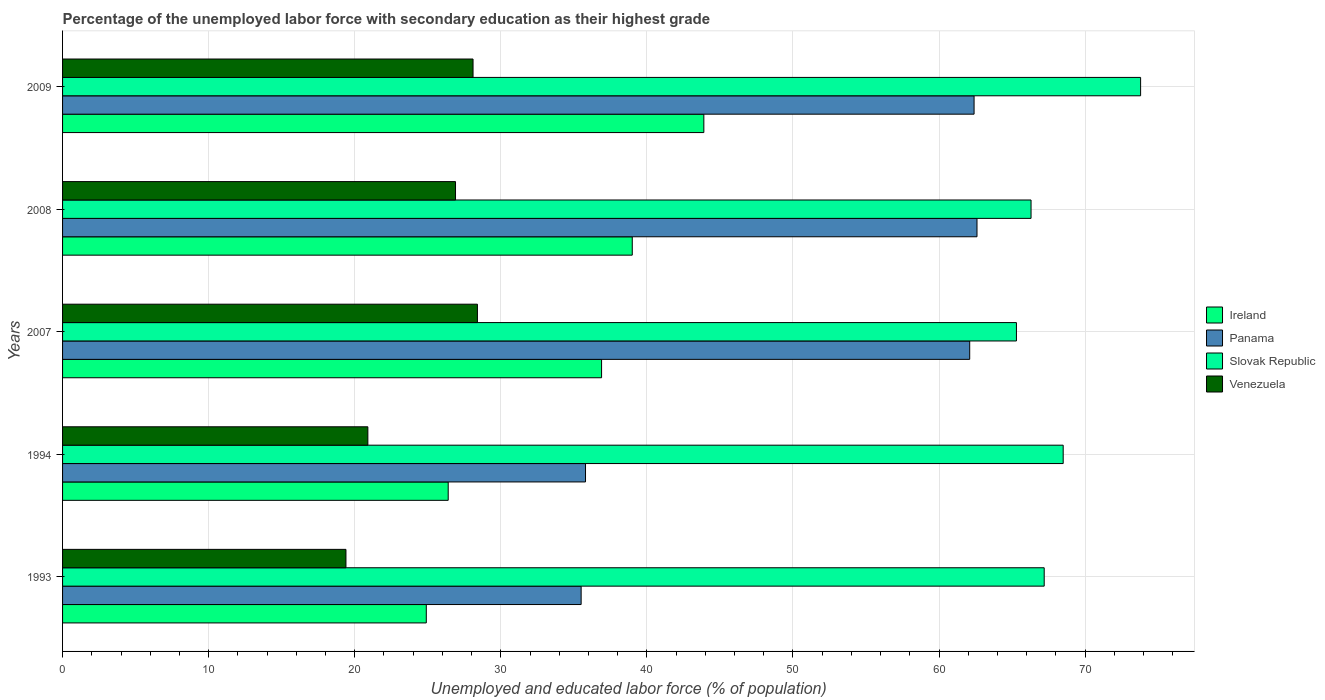How many different coloured bars are there?
Give a very brief answer. 4. Are the number of bars per tick equal to the number of legend labels?
Your response must be concise. Yes. Are the number of bars on each tick of the Y-axis equal?
Provide a short and direct response. Yes. How many bars are there on the 2nd tick from the top?
Your response must be concise. 4. What is the label of the 4th group of bars from the top?
Your answer should be very brief. 1994. What is the percentage of the unemployed labor force with secondary education in Panama in 1993?
Provide a succinct answer. 35.5. Across all years, what is the maximum percentage of the unemployed labor force with secondary education in Panama?
Provide a succinct answer. 62.6. Across all years, what is the minimum percentage of the unemployed labor force with secondary education in Panama?
Your answer should be very brief. 35.5. In which year was the percentage of the unemployed labor force with secondary education in Ireland minimum?
Ensure brevity in your answer.  1993. What is the total percentage of the unemployed labor force with secondary education in Slovak Republic in the graph?
Give a very brief answer. 341.1. What is the difference between the percentage of the unemployed labor force with secondary education in Venezuela in 1993 and that in 2008?
Your answer should be compact. -7.5. What is the difference between the percentage of the unemployed labor force with secondary education in Slovak Republic in 1994 and the percentage of the unemployed labor force with secondary education in Venezuela in 2008?
Offer a very short reply. 41.6. What is the average percentage of the unemployed labor force with secondary education in Ireland per year?
Make the answer very short. 34.22. In the year 1994, what is the difference between the percentage of the unemployed labor force with secondary education in Panama and percentage of the unemployed labor force with secondary education in Venezuela?
Provide a short and direct response. 14.9. What is the ratio of the percentage of the unemployed labor force with secondary education in Venezuela in 1994 to that in 2009?
Make the answer very short. 0.74. Is the percentage of the unemployed labor force with secondary education in Ireland in 1993 less than that in 1994?
Offer a very short reply. Yes. Is the difference between the percentage of the unemployed labor force with secondary education in Panama in 2007 and 2009 greater than the difference between the percentage of the unemployed labor force with secondary education in Venezuela in 2007 and 2009?
Provide a short and direct response. No. What is the difference between the highest and the second highest percentage of the unemployed labor force with secondary education in Ireland?
Your answer should be very brief. 4.9. What is the difference between the highest and the lowest percentage of the unemployed labor force with secondary education in Panama?
Offer a very short reply. 27.1. In how many years, is the percentage of the unemployed labor force with secondary education in Slovak Republic greater than the average percentage of the unemployed labor force with secondary education in Slovak Republic taken over all years?
Your response must be concise. 2. Is it the case that in every year, the sum of the percentage of the unemployed labor force with secondary education in Panama and percentage of the unemployed labor force with secondary education in Venezuela is greater than the sum of percentage of the unemployed labor force with secondary education in Ireland and percentage of the unemployed labor force with secondary education in Slovak Republic?
Ensure brevity in your answer.  No. What does the 2nd bar from the top in 1993 represents?
Give a very brief answer. Slovak Republic. What does the 4th bar from the bottom in 1994 represents?
Give a very brief answer. Venezuela. How many years are there in the graph?
Offer a terse response. 5. What is the difference between two consecutive major ticks on the X-axis?
Your answer should be very brief. 10. Where does the legend appear in the graph?
Make the answer very short. Center right. What is the title of the graph?
Ensure brevity in your answer.  Percentage of the unemployed labor force with secondary education as their highest grade. What is the label or title of the X-axis?
Give a very brief answer. Unemployed and educated labor force (% of population). What is the label or title of the Y-axis?
Offer a very short reply. Years. What is the Unemployed and educated labor force (% of population) in Ireland in 1993?
Ensure brevity in your answer.  24.9. What is the Unemployed and educated labor force (% of population) of Panama in 1993?
Provide a succinct answer. 35.5. What is the Unemployed and educated labor force (% of population) of Slovak Republic in 1993?
Keep it short and to the point. 67.2. What is the Unemployed and educated labor force (% of population) in Venezuela in 1993?
Provide a short and direct response. 19.4. What is the Unemployed and educated labor force (% of population) of Ireland in 1994?
Make the answer very short. 26.4. What is the Unemployed and educated labor force (% of population) of Panama in 1994?
Offer a very short reply. 35.8. What is the Unemployed and educated labor force (% of population) of Slovak Republic in 1994?
Make the answer very short. 68.5. What is the Unemployed and educated labor force (% of population) in Venezuela in 1994?
Provide a succinct answer. 20.9. What is the Unemployed and educated labor force (% of population) of Ireland in 2007?
Provide a short and direct response. 36.9. What is the Unemployed and educated labor force (% of population) in Panama in 2007?
Your answer should be very brief. 62.1. What is the Unemployed and educated labor force (% of population) in Slovak Republic in 2007?
Ensure brevity in your answer.  65.3. What is the Unemployed and educated labor force (% of population) of Venezuela in 2007?
Provide a short and direct response. 28.4. What is the Unemployed and educated labor force (% of population) in Panama in 2008?
Offer a terse response. 62.6. What is the Unemployed and educated labor force (% of population) of Slovak Republic in 2008?
Your answer should be compact. 66.3. What is the Unemployed and educated labor force (% of population) in Venezuela in 2008?
Provide a short and direct response. 26.9. What is the Unemployed and educated labor force (% of population) in Ireland in 2009?
Your response must be concise. 43.9. What is the Unemployed and educated labor force (% of population) in Panama in 2009?
Your answer should be compact. 62.4. What is the Unemployed and educated labor force (% of population) of Slovak Republic in 2009?
Ensure brevity in your answer.  73.8. What is the Unemployed and educated labor force (% of population) of Venezuela in 2009?
Make the answer very short. 28.1. Across all years, what is the maximum Unemployed and educated labor force (% of population) of Ireland?
Your response must be concise. 43.9. Across all years, what is the maximum Unemployed and educated labor force (% of population) of Panama?
Give a very brief answer. 62.6. Across all years, what is the maximum Unemployed and educated labor force (% of population) in Slovak Republic?
Provide a succinct answer. 73.8. Across all years, what is the maximum Unemployed and educated labor force (% of population) of Venezuela?
Offer a terse response. 28.4. Across all years, what is the minimum Unemployed and educated labor force (% of population) in Ireland?
Give a very brief answer. 24.9. Across all years, what is the minimum Unemployed and educated labor force (% of population) of Panama?
Your answer should be compact. 35.5. Across all years, what is the minimum Unemployed and educated labor force (% of population) of Slovak Republic?
Keep it short and to the point. 65.3. Across all years, what is the minimum Unemployed and educated labor force (% of population) in Venezuela?
Ensure brevity in your answer.  19.4. What is the total Unemployed and educated labor force (% of population) in Ireland in the graph?
Give a very brief answer. 171.1. What is the total Unemployed and educated labor force (% of population) in Panama in the graph?
Your response must be concise. 258.4. What is the total Unemployed and educated labor force (% of population) of Slovak Republic in the graph?
Keep it short and to the point. 341.1. What is the total Unemployed and educated labor force (% of population) in Venezuela in the graph?
Offer a terse response. 123.7. What is the difference between the Unemployed and educated labor force (% of population) in Ireland in 1993 and that in 1994?
Make the answer very short. -1.5. What is the difference between the Unemployed and educated labor force (% of population) of Panama in 1993 and that in 1994?
Provide a succinct answer. -0.3. What is the difference between the Unemployed and educated labor force (% of population) in Panama in 1993 and that in 2007?
Offer a terse response. -26.6. What is the difference between the Unemployed and educated labor force (% of population) in Slovak Republic in 1993 and that in 2007?
Your response must be concise. 1.9. What is the difference between the Unemployed and educated labor force (% of population) of Ireland in 1993 and that in 2008?
Make the answer very short. -14.1. What is the difference between the Unemployed and educated labor force (% of population) of Panama in 1993 and that in 2008?
Make the answer very short. -27.1. What is the difference between the Unemployed and educated labor force (% of population) of Ireland in 1993 and that in 2009?
Make the answer very short. -19. What is the difference between the Unemployed and educated labor force (% of population) in Panama in 1993 and that in 2009?
Your answer should be very brief. -26.9. What is the difference between the Unemployed and educated labor force (% of population) of Slovak Republic in 1993 and that in 2009?
Your answer should be very brief. -6.6. What is the difference between the Unemployed and educated labor force (% of population) in Panama in 1994 and that in 2007?
Provide a succinct answer. -26.3. What is the difference between the Unemployed and educated labor force (% of population) of Slovak Republic in 1994 and that in 2007?
Offer a very short reply. 3.2. What is the difference between the Unemployed and educated labor force (% of population) of Venezuela in 1994 and that in 2007?
Keep it short and to the point. -7.5. What is the difference between the Unemployed and educated labor force (% of population) in Ireland in 1994 and that in 2008?
Offer a terse response. -12.6. What is the difference between the Unemployed and educated labor force (% of population) of Panama in 1994 and that in 2008?
Provide a short and direct response. -26.8. What is the difference between the Unemployed and educated labor force (% of population) in Ireland in 1994 and that in 2009?
Your answer should be very brief. -17.5. What is the difference between the Unemployed and educated labor force (% of population) in Panama in 1994 and that in 2009?
Make the answer very short. -26.6. What is the difference between the Unemployed and educated labor force (% of population) of Venezuela in 1994 and that in 2009?
Ensure brevity in your answer.  -7.2. What is the difference between the Unemployed and educated labor force (% of population) of Slovak Republic in 2007 and that in 2008?
Your answer should be very brief. -1. What is the difference between the Unemployed and educated labor force (% of population) in Panama in 2007 and that in 2009?
Offer a very short reply. -0.3. What is the difference between the Unemployed and educated labor force (% of population) in Slovak Republic in 2007 and that in 2009?
Your answer should be compact. -8.5. What is the difference between the Unemployed and educated labor force (% of population) of Ireland in 2008 and that in 2009?
Your answer should be compact. -4.9. What is the difference between the Unemployed and educated labor force (% of population) of Panama in 2008 and that in 2009?
Offer a terse response. 0.2. What is the difference between the Unemployed and educated labor force (% of population) of Slovak Republic in 2008 and that in 2009?
Offer a very short reply. -7.5. What is the difference between the Unemployed and educated labor force (% of population) in Venezuela in 2008 and that in 2009?
Offer a terse response. -1.2. What is the difference between the Unemployed and educated labor force (% of population) in Ireland in 1993 and the Unemployed and educated labor force (% of population) in Panama in 1994?
Offer a terse response. -10.9. What is the difference between the Unemployed and educated labor force (% of population) in Ireland in 1993 and the Unemployed and educated labor force (% of population) in Slovak Republic in 1994?
Ensure brevity in your answer.  -43.6. What is the difference between the Unemployed and educated labor force (% of population) in Panama in 1993 and the Unemployed and educated labor force (% of population) in Slovak Republic in 1994?
Provide a succinct answer. -33. What is the difference between the Unemployed and educated labor force (% of population) in Panama in 1993 and the Unemployed and educated labor force (% of population) in Venezuela in 1994?
Keep it short and to the point. 14.6. What is the difference between the Unemployed and educated labor force (% of population) of Slovak Republic in 1993 and the Unemployed and educated labor force (% of population) of Venezuela in 1994?
Make the answer very short. 46.3. What is the difference between the Unemployed and educated labor force (% of population) of Ireland in 1993 and the Unemployed and educated labor force (% of population) of Panama in 2007?
Provide a succinct answer. -37.2. What is the difference between the Unemployed and educated labor force (% of population) in Ireland in 1993 and the Unemployed and educated labor force (% of population) in Slovak Republic in 2007?
Your answer should be compact. -40.4. What is the difference between the Unemployed and educated labor force (% of population) of Ireland in 1993 and the Unemployed and educated labor force (% of population) of Venezuela in 2007?
Ensure brevity in your answer.  -3.5. What is the difference between the Unemployed and educated labor force (% of population) of Panama in 1993 and the Unemployed and educated labor force (% of population) of Slovak Republic in 2007?
Your answer should be compact. -29.8. What is the difference between the Unemployed and educated labor force (% of population) of Panama in 1993 and the Unemployed and educated labor force (% of population) of Venezuela in 2007?
Your response must be concise. 7.1. What is the difference between the Unemployed and educated labor force (% of population) in Slovak Republic in 1993 and the Unemployed and educated labor force (% of population) in Venezuela in 2007?
Give a very brief answer. 38.8. What is the difference between the Unemployed and educated labor force (% of population) in Ireland in 1993 and the Unemployed and educated labor force (% of population) in Panama in 2008?
Your answer should be compact. -37.7. What is the difference between the Unemployed and educated labor force (% of population) of Ireland in 1993 and the Unemployed and educated labor force (% of population) of Slovak Republic in 2008?
Your answer should be compact. -41.4. What is the difference between the Unemployed and educated labor force (% of population) in Panama in 1993 and the Unemployed and educated labor force (% of population) in Slovak Republic in 2008?
Provide a short and direct response. -30.8. What is the difference between the Unemployed and educated labor force (% of population) in Slovak Republic in 1993 and the Unemployed and educated labor force (% of population) in Venezuela in 2008?
Your answer should be compact. 40.3. What is the difference between the Unemployed and educated labor force (% of population) in Ireland in 1993 and the Unemployed and educated labor force (% of population) in Panama in 2009?
Give a very brief answer. -37.5. What is the difference between the Unemployed and educated labor force (% of population) of Ireland in 1993 and the Unemployed and educated labor force (% of population) of Slovak Republic in 2009?
Your answer should be compact. -48.9. What is the difference between the Unemployed and educated labor force (% of population) of Panama in 1993 and the Unemployed and educated labor force (% of population) of Slovak Republic in 2009?
Make the answer very short. -38.3. What is the difference between the Unemployed and educated labor force (% of population) of Panama in 1993 and the Unemployed and educated labor force (% of population) of Venezuela in 2009?
Offer a terse response. 7.4. What is the difference between the Unemployed and educated labor force (% of population) of Slovak Republic in 1993 and the Unemployed and educated labor force (% of population) of Venezuela in 2009?
Provide a succinct answer. 39.1. What is the difference between the Unemployed and educated labor force (% of population) in Ireland in 1994 and the Unemployed and educated labor force (% of population) in Panama in 2007?
Offer a terse response. -35.7. What is the difference between the Unemployed and educated labor force (% of population) of Ireland in 1994 and the Unemployed and educated labor force (% of population) of Slovak Republic in 2007?
Your answer should be very brief. -38.9. What is the difference between the Unemployed and educated labor force (% of population) in Ireland in 1994 and the Unemployed and educated labor force (% of population) in Venezuela in 2007?
Offer a very short reply. -2. What is the difference between the Unemployed and educated labor force (% of population) in Panama in 1994 and the Unemployed and educated labor force (% of population) in Slovak Republic in 2007?
Offer a very short reply. -29.5. What is the difference between the Unemployed and educated labor force (% of population) of Panama in 1994 and the Unemployed and educated labor force (% of population) of Venezuela in 2007?
Your response must be concise. 7.4. What is the difference between the Unemployed and educated labor force (% of population) of Slovak Republic in 1994 and the Unemployed and educated labor force (% of population) of Venezuela in 2007?
Make the answer very short. 40.1. What is the difference between the Unemployed and educated labor force (% of population) in Ireland in 1994 and the Unemployed and educated labor force (% of population) in Panama in 2008?
Offer a very short reply. -36.2. What is the difference between the Unemployed and educated labor force (% of population) in Ireland in 1994 and the Unemployed and educated labor force (% of population) in Slovak Republic in 2008?
Keep it short and to the point. -39.9. What is the difference between the Unemployed and educated labor force (% of population) in Panama in 1994 and the Unemployed and educated labor force (% of population) in Slovak Republic in 2008?
Your answer should be very brief. -30.5. What is the difference between the Unemployed and educated labor force (% of population) of Panama in 1994 and the Unemployed and educated labor force (% of population) of Venezuela in 2008?
Your response must be concise. 8.9. What is the difference between the Unemployed and educated labor force (% of population) of Slovak Republic in 1994 and the Unemployed and educated labor force (% of population) of Venezuela in 2008?
Offer a terse response. 41.6. What is the difference between the Unemployed and educated labor force (% of population) in Ireland in 1994 and the Unemployed and educated labor force (% of population) in Panama in 2009?
Keep it short and to the point. -36. What is the difference between the Unemployed and educated labor force (% of population) of Ireland in 1994 and the Unemployed and educated labor force (% of population) of Slovak Republic in 2009?
Keep it short and to the point. -47.4. What is the difference between the Unemployed and educated labor force (% of population) in Ireland in 1994 and the Unemployed and educated labor force (% of population) in Venezuela in 2009?
Ensure brevity in your answer.  -1.7. What is the difference between the Unemployed and educated labor force (% of population) in Panama in 1994 and the Unemployed and educated labor force (% of population) in Slovak Republic in 2009?
Ensure brevity in your answer.  -38. What is the difference between the Unemployed and educated labor force (% of population) in Panama in 1994 and the Unemployed and educated labor force (% of population) in Venezuela in 2009?
Your answer should be compact. 7.7. What is the difference between the Unemployed and educated labor force (% of population) in Slovak Republic in 1994 and the Unemployed and educated labor force (% of population) in Venezuela in 2009?
Ensure brevity in your answer.  40.4. What is the difference between the Unemployed and educated labor force (% of population) in Ireland in 2007 and the Unemployed and educated labor force (% of population) in Panama in 2008?
Your response must be concise. -25.7. What is the difference between the Unemployed and educated labor force (% of population) of Ireland in 2007 and the Unemployed and educated labor force (% of population) of Slovak Republic in 2008?
Provide a short and direct response. -29.4. What is the difference between the Unemployed and educated labor force (% of population) in Panama in 2007 and the Unemployed and educated labor force (% of population) in Venezuela in 2008?
Provide a short and direct response. 35.2. What is the difference between the Unemployed and educated labor force (% of population) in Slovak Republic in 2007 and the Unemployed and educated labor force (% of population) in Venezuela in 2008?
Provide a short and direct response. 38.4. What is the difference between the Unemployed and educated labor force (% of population) of Ireland in 2007 and the Unemployed and educated labor force (% of population) of Panama in 2009?
Offer a terse response. -25.5. What is the difference between the Unemployed and educated labor force (% of population) of Ireland in 2007 and the Unemployed and educated labor force (% of population) of Slovak Republic in 2009?
Provide a short and direct response. -36.9. What is the difference between the Unemployed and educated labor force (% of population) of Ireland in 2007 and the Unemployed and educated labor force (% of population) of Venezuela in 2009?
Ensure brevity in your answer.  8.8. What is the difference between the Unemployed and educated labor force (% of population) of Panama in 2007 and the Unemployed and educated labor force (% of population) of Slovak Republic in 2009?
Keep it short and to the point. -11.7. What is the difference between the Unemployed and educated labor force (% of population) in Panama in 2007 and the Unemployed and educated labor force (% of population) in Venezuela in 2009?
Your response must be concise. 34. What is the difference between the Unemployed and educated labor force (% of population) of Slovak Republic in 2007 and the Unemployed and educated labor force (% of population) of Venezuela in 2009?
Offer a very short reply. 37.2. What is the difference between the Unemployed and educated labor force (% of population) in Ireland in 2008 and the Unemployed and educated labor force (% of population) in Panama in 2009?
Make the answer very short. -23.4. What is the difference between the Unemployed and educated labor force (% of population) in Ireland in 2008 and the Unemployed and educated labor force (% of population) in Slovak Republic in 2009?
Offer a terse response. -34.8. What is the difference between the Unemployed and educated labor force (% of population) of Ireland in 2008 and the Unemployed and educated labor force (% of population) of Venezuela in 2009?
Offer a very short reply. 10.9. What is the difference between the Unemployed and educated labor force (% of population) in Panama in 2008 and the Unemployed and educated labor force (% of population) in Venezuela in 2009?
Keep it short and to the point. 34.5. What is the difference between the Unemployed and educated labor force (% of population) of Slovak Republic in 2008 and the Unemployed and educated labor force (% of population) of Venezuela in 2009?
Your response must be concise. 38.2. What is the average Unemployed and educated labor force (% of population) of Ireland per year?
Give a very brief answer. 34.22. What is the average Unemployed and educated labor force (% of population) of Panama per year?
Ensure brevity in your answer.  51.68. What is the average Unemployed and educated labor force (% of population) of Slovak Republic per year?
Offer a terse response. 68.22. What is the average Unemployed and educated labor force (% of population) of Venezuela per year?
Make the answer very short. 24.74. In the year 1993, what is the difference between the Unemployed and educated labor force (% of population) in Ireland and Unemployed and educated labor force (% of population) in Slovak Republic?
Keep it short and to the point. -42.3. In the year 1993, what is the difference between the Unemployed and educated labor force (% of population) of Ireland and Unemployed and educated labor force (% of population) of Venezuela?
Your response must be concise. 5.5. In the year 1993, what is the difference between the Unemployed and educated labor force (% of population) of Panama and Unemployed and educated labor force (% of population) of Slovak Republic?
Your answer should be very brief. -31.7. In the year 1993, what is the difference between the Unemployed and educated labor force (% of population) in Slovak Republic and Unemployed and educated labor force (% of population) in Venezuela?
Ensure brevity in your answer.  47.8. In the year 1994, what is the difference between the Unemployed and educated labor force (% of population) of Ireland and Unemployed and educated labor force (% of population) of Slovak Republic?
Ensure brevity in your answer.  -42.1. In the year 1994, what is the difference between the Unemployed and educated labor force (% of population) in Ireland and Unemployed and educated labor force (% of population) in Venezuela?
Provide a short and direct response. 5.5. In the year 1994, what is the difference between the Unemployed and educated labor force (% of population) in Panama and Unemployed and educated labor force (% of population) in Slovak Republic?
Your answer should be very brief. -32.7. In the year 1994, what is the difference between the Unemployed and educated labor force (% of population) of Panama and Unemployed and educated labor force (% of population) of Venezuela?
Provide a succinct answer. 14.9. In the year 1994, what is the difference between the Unemployed and educated labor force (% of population) in Slovak Republic and Unemployed and educated labor force (% of population) in Venezuela?
Offer a terse response. 47.6. In the year 2007, what is the difference between the Unemployed and educated labor force (% of population) in Ireland and Unemployed and educated labor force (% of population) in Panama?
Give a very brief answer. -25.2. In the year 2007, what is the difference between the Unemployed and educated labor force (% of population) of Ireland and Unemployed and educated labor force (% of population) of Slovak Republic?
Your response must be concise. -28.4. In the year 2007, what is the difference between the Unemployed and educated labor force (% of population) of Ireland and Unemployed and educated labor force (% of population) of Venezuela?
Your answer should be compact. 8.5. In the year 2007, what is the difference between the Unemployed and educated labor force (% of population) in Panama and Unemployed and educated labor force (% of population) in Venezuela?
Keep it short and to the point. 33.7. In the year 2007, what is the difference between the Unemployed and educated labor force (% of population) in Slovak Republic and Unemployed and educated labor force (% of population) in Venezuela?
Give a very brief answer. 36.9. In the year 2008, what is the difference between the Unemployed and educated labor force (% of population) of Ireland and Unemployed and educated labor force (% of population) of Panama?
Your response must be concise. -23.6. In the year 2008, what is the difference between the Unemployed and educated labor force (% of population) in Ireland and Unemployed and educated labor force (% of population) in Slovak Republic?
Your response must be concise. -27.3. In the year 2008, what is the difference between the Unemployed and educated labor force (% of population) in Ireland and Unemployed and educated labor force (% of population) in Venezuela?
Keep it short and to the point. 12.1. In the year 2008, what is the difference between the Unemployed and educated labor force (% of population) in Panama and Unemployed and educated labor force (% of population) in Slovak Republic?
Your response must be concise. -3.7. In the year 2008, what is the difference between the Unemployed and educated labor force (% of population) of Panama and Unemployed and educated labor force (% of population) of Venezuela?
Your response must be concise. 35.7. In the year 2008, what is the difference between the Unemployed and educated labor force (% of population) of Slovak Republic and Unemployed and educated labor force (% of population) of Venezuela?
Give a very brief answer. 39.4. In the year 2009, what is the difference between the Unemployed and educated labor force (% of population) in Ireland and Unemployed and educated labor force (% of population) in Panama?
Provide a short and direct response. -18.5. In the year 2009, what is the difference between the Unemployed and educated labor force (% of population) of Ireland and Unemployed and educated labor force (% of population) of Slovak Republic?
Your response must be concise. -29.9. In the year 2009, what is the difference between the Unemployed and educated labor force (% of population) of Ireland and Unemployed and educated labor force (% of population) of Venezuela?
Your answer should be compact. 15.8. In the year 2009, what is the difference between the Unemployed and educated labor force (% of population) of Panama and Unemployed and educated labor force (% of population) of Venezuela?
Keep it short and to the point. 34.3. In the year 2009, what is the difference between the Unemployed and educated labor force (% of population) of Slovak Republic and Unemployed and educated labor force (% of population) of Venezuela?
Offer a very short reply. 45.7. What is the ratio of the Unemployed and educated labor force (% of population) in Ireland in 1993 to that in 1994?
Your answer should be very brief. 0.94. What is the ratio of the Unemployed and educated labor force (% of population) in Panama in 1993 to that in 1994?
Make the answer very short. 0.99. What is the ratio of the Unemployed and educated labor force (% of population) in Venezuela in 1993 to that in 1994?
Provide a short and direct response. 0.93. What is the ratio of the Unemployed and educated labor force (% of population) in Ireland in 1993 to that in 2007?
Offer a very short reply. 0.67. What is the ratio of the Unemployed and educated labor force (% of population) in Panama in 1993 to that in 2007?
Ensure brevity in your answer.  0.57. What is the ratio of the Unemployed and educated labor force (% of population) in Slovak Republic in 1993 to that in 2007?
Your answer should be very brief. 1.03. What is the ratio of the Unemployed and educated labor force (% of population) in Venezuela in 1993 to that in 2007?
Ensure brevity in your answer.  0.68. What is the ratio of the Unemployed and educated labor force (% of population) of Ireland in 1993 to that in 2008?
Make the answer very short. 0.64. What is the ratio of the Unemployed and educated labor force (% of population) in Panama in 1993 to that in 2008?
Keep it short and to the point. 0.57. What is the ratio of the Unemployed and educated labor force (% of population) of Slovak Republic in 1993 to that in 2008?
Make the answer very short. 1.01. What is the ratio of the Unemployed and educated labor force (% of population) of Venezuela in 1993 to that in 2008?
Give a very brief answer. 0.72. What is the ratio of the Unemployed and educated labor force (% of population) of Ireland in 1993 to that in 2009?
Keep it short and to the point. 0.57. What is the ratio of the Unemployed and educated labor force (% of population) of Panama in 1993 to that in 2009?
Your answer should be compact. 0.57. What is the ratio of the Unemployed and educated labor force (% of population) of Slovak Republic in 1993 to that in 2009?
Ensure brevity in your answer.  0.91. What is the ratio of the Unemployed and educated labor force (% of population) of Venezuela in 1993 to that in 2009?
Offer a terse response. 0.69. What is the ratio of the Unemployed and educated labor force (% of population) of Ireland in 1994 to that in 2007?
Your response must be concise. 0.72. What is the ratio of the Unemployed and educated labor force (% of population) in Panama in 1994 to that in 2007?
Provide a succinct answer. 0.58. What is the ratio of the Unemployed and educated labor force (% of population) of Slovak Republic in 1994 to that in 2007?
Provide a short and direct response. 1.05. What is the ratio of the Unemployed and educated labor force (% of population) of Venezuela in 1994 to that in 2007?
Make the answer very short. 0.74. What is the ratio of the Unemployed and educated labor force (% of population) of Ireland in 1994 to that in 2008?
Offer a very short reply. 0.68. What is the ratio of the Unemployed and educated labor force (% of population) in Panama in 1994 to that in 2008?
Your response must be concise. 0.57. What is the ratio of the Unemployed and educated labor force (% of population) in Slovak Republic in 1994 to that in 2008?
Make the answer very short. 1.03. What is the ratio of the Unemployed and educated labor force (% of population) of Venezuela in 1994 to that in 2008?
Provide a short and direct response. 0.78. What is the ratio of the Unemployed and educated labor force (% of population) in Ireland in 1994 to that in 2009?
Keep it short and to the point. 0.6. What is the ratio of the Unemployed and educated labor force (% of population) in Panama in 1994 to that in 2009?
Your answer should be compact. 0.57. What is the ratio of the Unemployed and educated labor force (% of population) of Slovak Republic in 1994 to that in 2009?
Your response must be concise. 0.93. What is the ratio of the Unemployed and educated labor force (% of population) in Venezuela in 1994 to that in 2009?
Give a very brief answer. 0.74. What is the ratio of the Unemployed and educated labor force (% of population) of Ireland in 2007 to that in 2008?
Your answer should be very brief. 0.95. What is the ratio of the Unemployed and educated labor force (% of population) of Slovak Republic in 2007 to that in 2008?
Your answer should be very brief. 0.98. What is the ratio of the Unemployed and educated labor force (% of population) of Venezuela in 2007 to that in 2008?
Ensure brevity in your answer.  1.06. What is the ratio of the Unemployed and educated labor force (% of population) in Ireland in 2007 to that in 2009?
Provide a succinct answer. 0.84. What is the ratio of the Unemployed and educated labor force (% of population) in Slovak Republic in 2007 to that in 2009?
Your answer should be very brief. 0.88. What is the ratio of the Unemployed and educated labor force (% of population) in Venezuela in 2007 to that in 2009?
Make the answer very short. 1.01. What is the ratio of the Unemployed and educated labor force (% of population) of Ireland in 2008 to that in 2009?
Your answer should be compact. 0.89. What is the ratio of the Unemployed and educated labor force (% of population) of Panama in 2008 to that in 2009?
Give a very brief answer. 1. What is the ratio of the Unemployed and educated labor force (% of population) of Slovak Republic in 2008 to that in 2009?
Keep it short and to the point. 0.9. What is the ratio of the Unemployed and educated labor force (% of population) in Venezuela in 2008 to that in 2009?
Offer a very short reply. 0.96. What is the difference between the highest and the second highest Unemployed and educated labor force (% of population) in Panama?
Give a very brief answer. 0.2. What is the difference between the highest and the second highest Unemployed and educated labor force (% of population) of Slovak Republic?
Offer a very short reply. 5.3. What is the difference between the highest and the second highest Unemployed and educated labor force (% of population) in Venezuela?
Give a very brief answer. 0.3. What is the difference between the highest and the lowest Unemployed and educated labor force (% of population) in Ireland?
Ensure brevity in your answer.  19. What is the difference between the highest and the lowest Unemployed and educated labor force (% of population) of Panama?
Your answer should be compact. 27.1. What is the difference between the highest and the lowest Unemployed and educated labor force (% of population) in Slovak Republic?
Your response must be concise. 8.5. What is the difference between the highest and the lowest Unemployed and educated labor force (% of population) of Venezuela?
Your response must be concise. 9. 